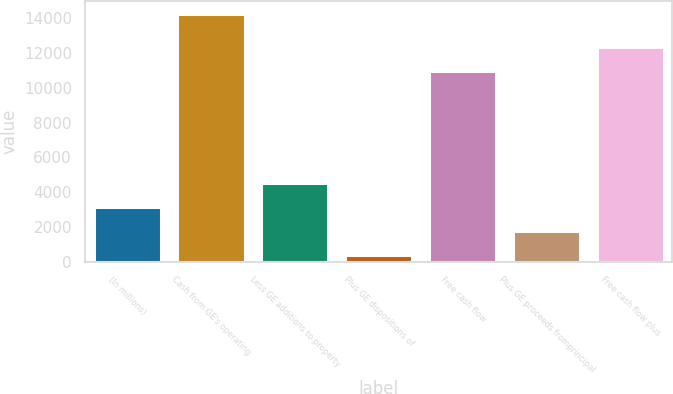Convert chart. <chart><loc_0><loc_0><loc_500><loc_500><bar_chart><fcel>(In millions)<fcel>Cash from GE's operating<fcel>Less GE additions to property<fcel>Plus GE dispositions of<fcel>Free cash flow<fcel>Plus GE proceeds fromprincipal<fcel>Free cash flow plus<nl><fcel>3155.8<fcel>14255<fcel>4543.2<fcel>381<fcel>10956<fcel>1768.4<fcel>12343.4<nl></chart> 